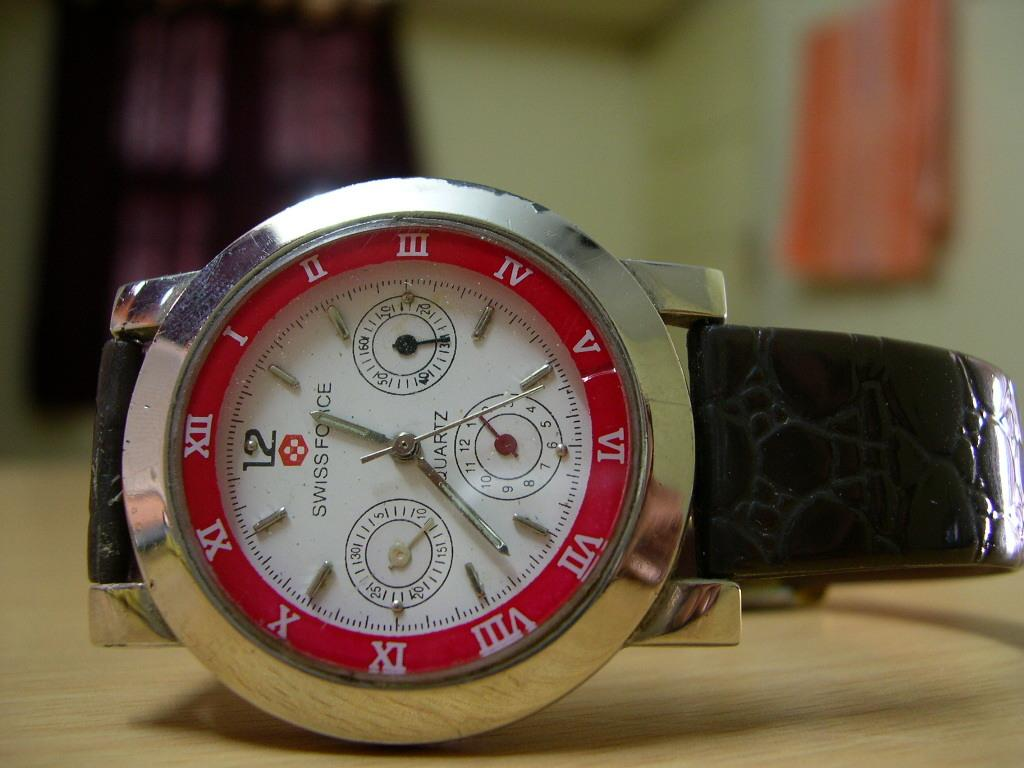<image>
Share a concise interpretation of the image provided. A swiss force watch that has roman numerals on it as well as a standard 12. 